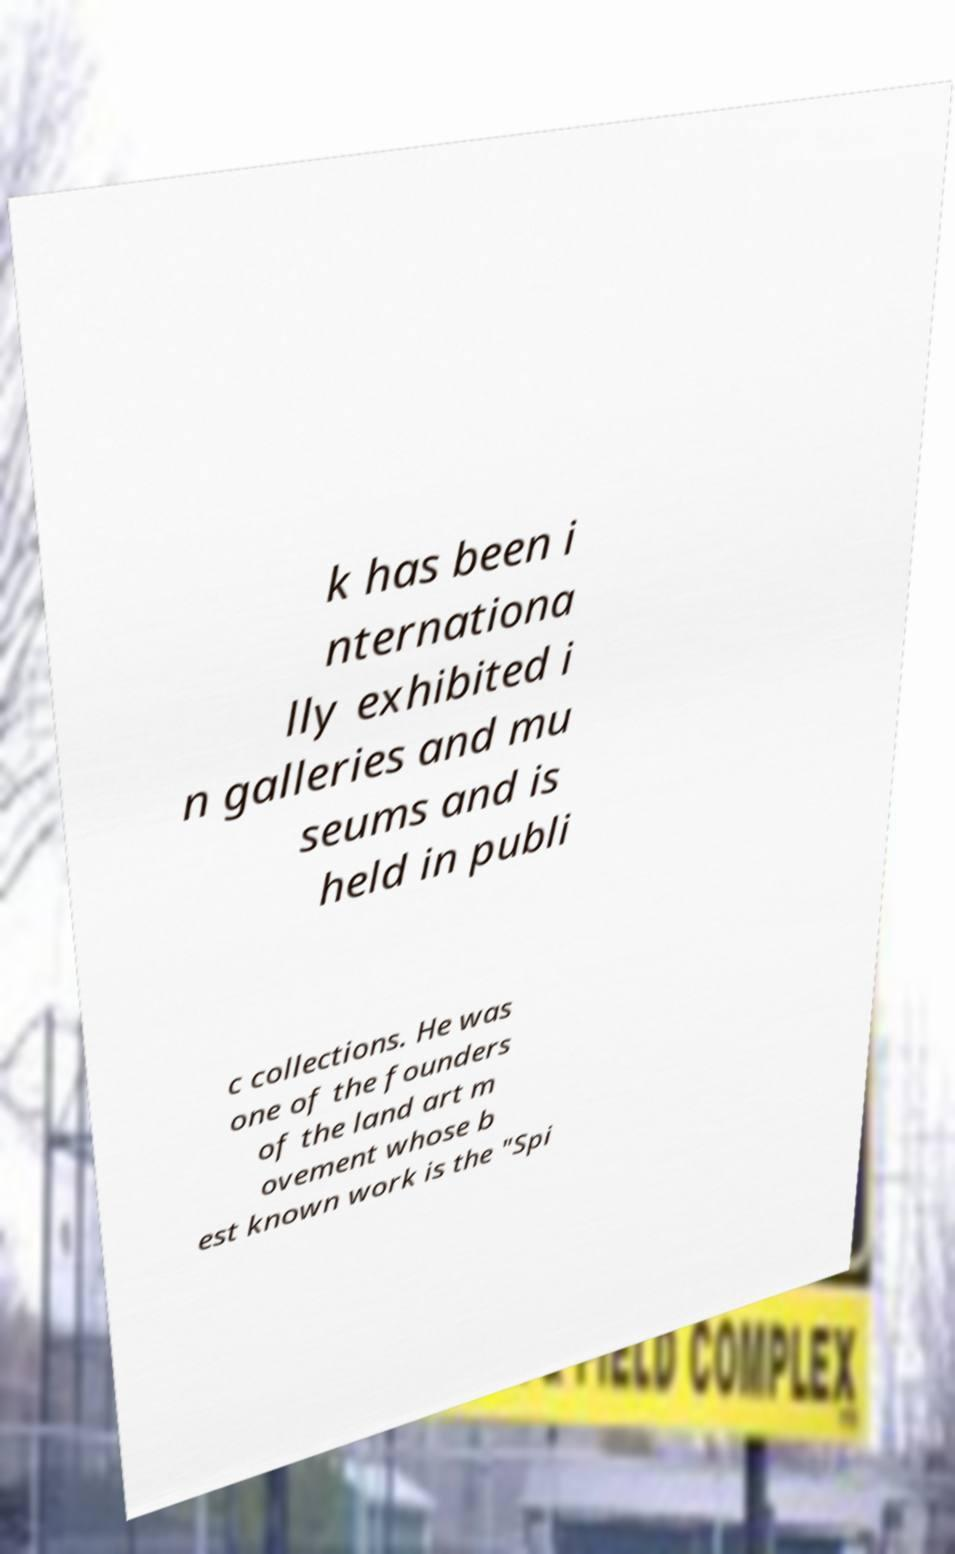For documentation purposes, I need the text within this image transcribed. Could you provide that? k has been i nternationa lly exhibited i n galleries and mu seums and is held in publi c collections. He was one of the founders of the land art m ovement whose b est known work is the "Spi 